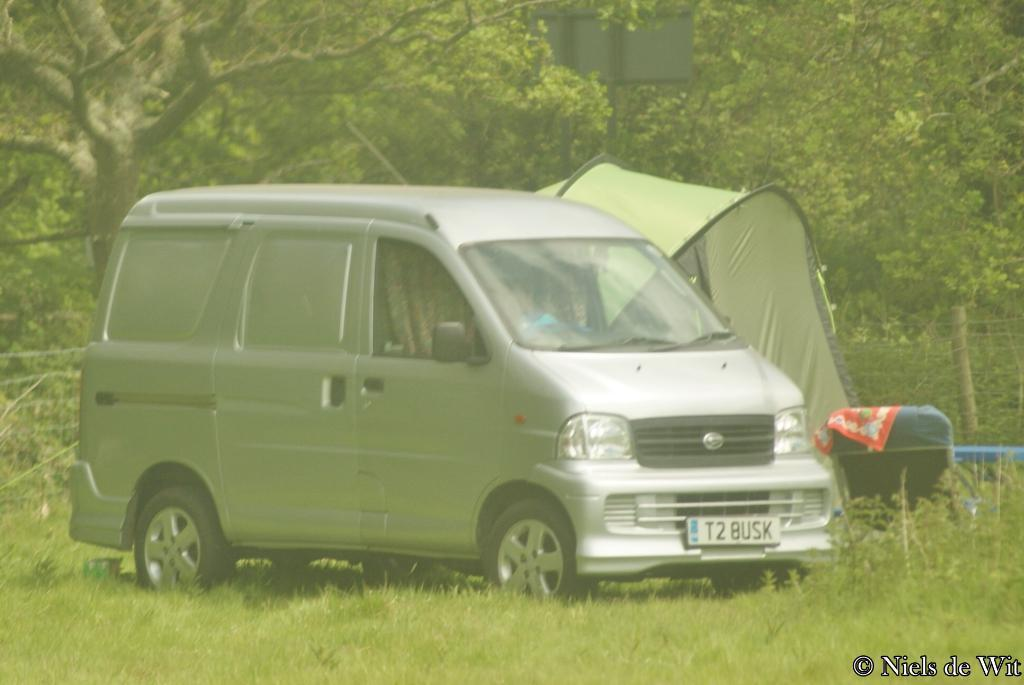<image>
Summarize the visual content of the image. A van with the license plate number T2BUSK sits in a green field 